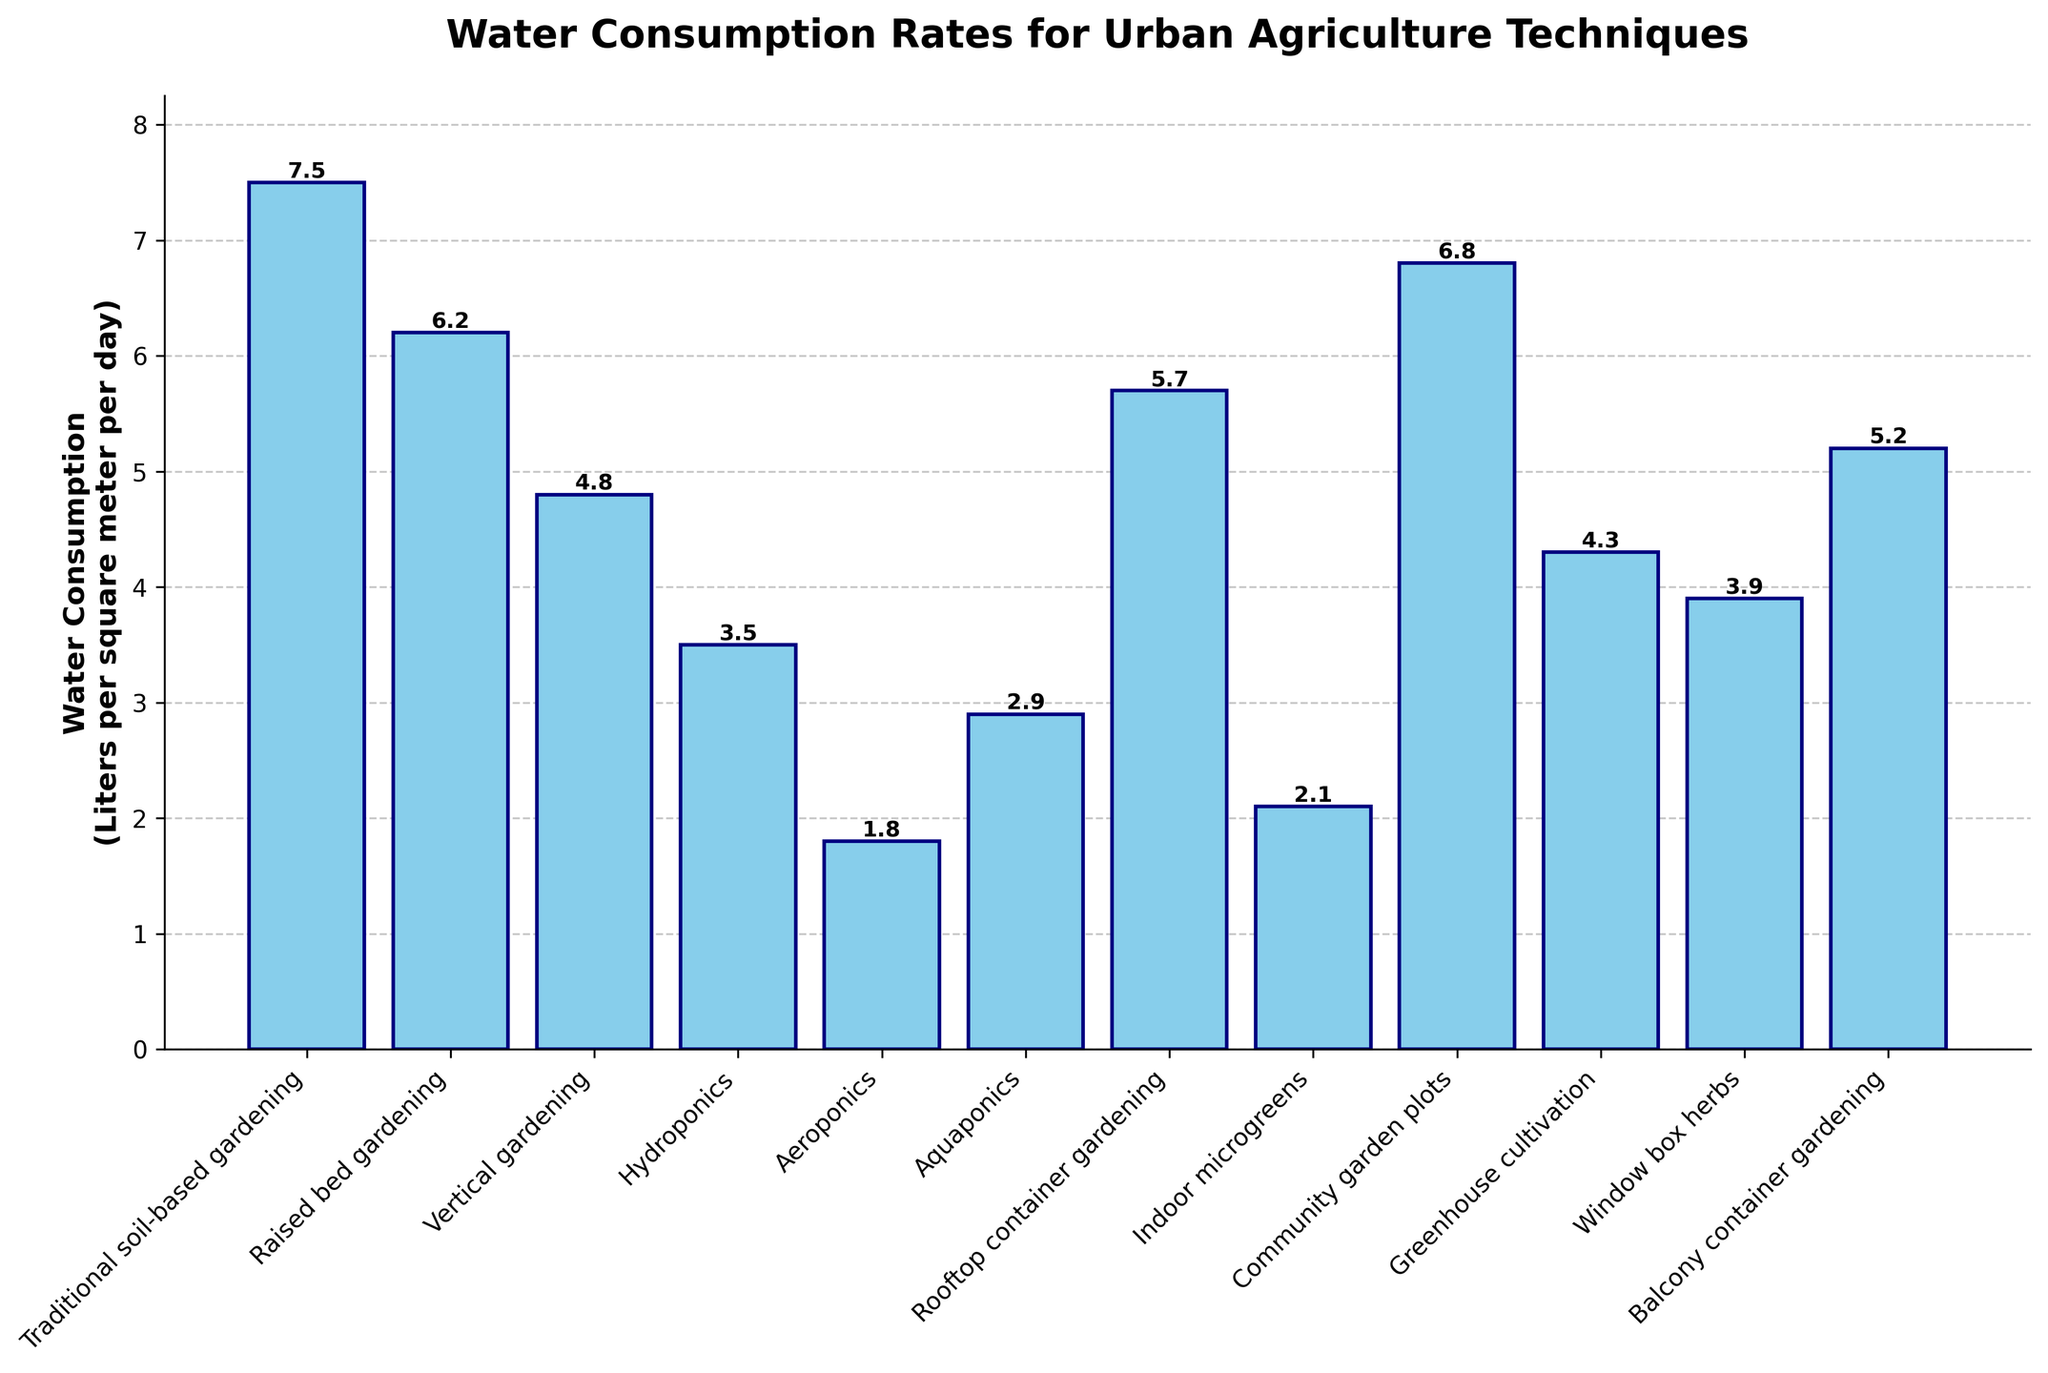Which urban agriculture technique has the highest water consumption? The highest bar represents the technique with the highest water consumption. "Traditional soil-based gardening" has the tallest bar with a water consumption of 7.5 liters per square meter per day.
Answer: Traditional soil-based gardening What is the difference in water consumption between hydroponics and aeroponics? Find the heights of the bars representing hydroponics and aeroponics. Hydroponics consumes 3.5 liters per square meter per day, and aeroponics consumes 1.8 liters. The difference is 3.5 - 1.8 = 1.7 liters.
Answer: 1.7 liters Which techniques have water consumption rates less than 3 liters per square meter per day? Identify bars with heights less than 3. Both aeroponics (1.8) and indoor microgreens (2.1) have consumption rates under 3 liters per square meter per day.
Answer: Aeroponics, Indoor microgreens How much more water does a traditional soil-based garden consume compared to a rooftop container garden? Find the heights of the bars representing "traditional soil-based gardening" and "rooftop container gardening". Traditional soil-based gardening consumes 7.5 liters, and rooftop container gardening consumes 5.7 liters. The difference is 7.5 - 5.7 = 1.8 liters.
Answer: 1.8 liters Rank the following techniques from highest to lowest water consumption: vertical gardening, aquaponics, and window box herbs. Compare the heights of the bars for the listed techniques. Vertical gardening (4.8), aquaponics (2.9), and window box herbs (3.9). Ordering from highest to lowest: Vertical gardening, window box herbs, aquaponics.
Answer: Vertical gardening, Window box herbs, Aquaponics Which technique has a water consumption rate closest to the median value of all other techniques? Arrange all the water consumption rates and find the median. The rates in ascending order are: 1.8, 2.1, 2.9, 3.5, 3.9, 4.3, 4.8, 5.2, 5.7, 6.2, 6.8, 7.5. The median (middle value) is the average of the 6th (4.3) and 7th (4.8) values: (4.3 + 4.8) / 2 = 4.55. The technique closest to 4.55 is vertical gardening at 4.8.
Answer: Vertical gardening Are there more techniques with water consumption rates greater than or less than 4 liters per square meter per day? Count the number of techniques with water consumption rates greater than and less than 4 liters. Rates greater than 4: 4.3, 4.8, 5.2, 5.7, 6.2, 6.8, 7.5 (7 techniques). Rates less than 4: 1.8, 2.1, 2.9, 3.5, 3.9 (5 techniques). There are more techniques with rates greater than 4 liters.
Answer: Greater than 4 liters What is the average water consumption of techniques consuming more than 5 liters per square meter per day? Identify techniques consuming more than 5 liters and calculate their average. Techniques are: Traditional soil-based gardening (7.5), raised bed gardening (6.2), community garden plots (6.8), rooftop container gardening (5.7), balcony container gardening (5.2). Sum: 7.5 + 6.2 + 6.8 + 5.7 + 5.2 = 31.4. Average: 31.4 / 5 ≈ 6.28 liters.
Answer: ~6.28 liters 